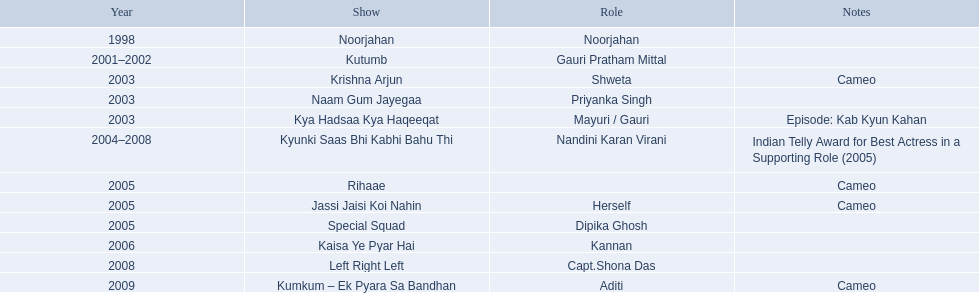What are all of the shows? Noorjahan, Kutumb, Krishna Arjun, Naam Gum Jayegaa, Kya Hadsaa Kya Haqeeqat, Kyunki Saas Bhi Kabhi Bahu Thi, Rihaae, Jassi Jaisi Koi Nahin, Special Squad, Kaisa Ye Pyar Hai, Left Right Left, Kumkum – Ek Pyara Sa Bandhan. When were they in production? 1998, 2001–2002, 2003, 2003, 2003, 2004–2008, 2005, 2005, 2005, 2006, 2008, 2009. And which show was he on for the longest time? Kyunki Saas Bhi Kabhi Bahu Thi. 